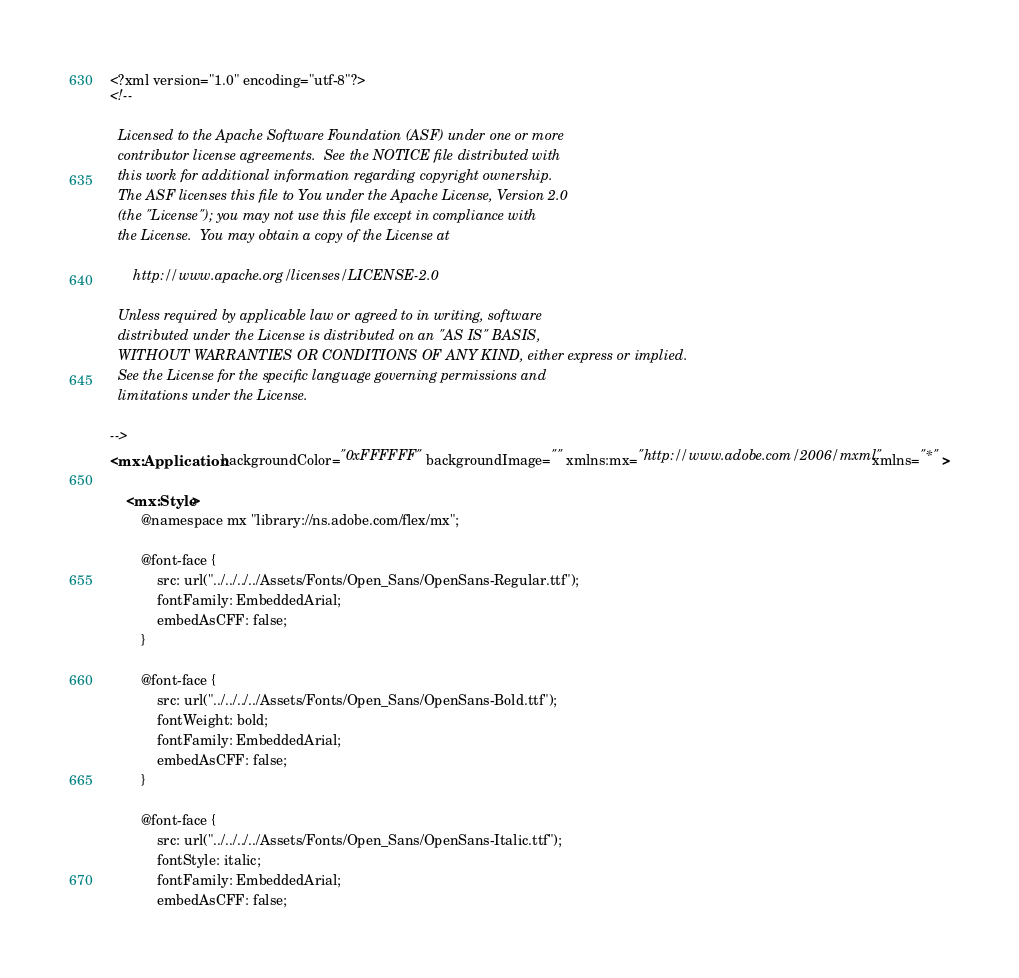<code> <loc_0><loc_0><loc_500><loc_500><_XML_><?xml version="1.0" encoding="utf-8"?>
<!--

  Licensed to the Apache Software Foundation (ASF) under one or more
  contributor license agreements.  See the NOTICE file distributed with
  this work for additional information regarding copyright ownership.
  The ASF licenses this file to You under the Apache License, Version 2.0
  (the "License"); you may not use this file except in compliance with
  the License.  You may obtain a copy of the License at

      http://www.apache.org/licenses/LICENSE-2.0

  Unless required by applicable law or agreed to in writing, software
  distributed under the License is distributed on an "AS IS" BASIS,
  WITHOUT WARRANTIES OR CONDITIONS OF ANY KIND, either express or implied.
  See the License for the specific language governing permissions and
  limitations under the License.

-->
<mx:Application backgroundColor="0xFFFFFF" backgroundImage="" xmlns:mx="http://www.adobe.com/2006/mxml" xmlns="*" >

	<mx:Style>
		@namespace mx "library://ns.adobe.com/flex/mx";
		
		@font-face {
			src: url("../../../../Assets/Fonts/Open_Sans/OpenSans-Regular.ttf");
			fontFamily: EmbeddedArial;
			embedAsCFF: false;
		}

		@font-face {
			src: url("../../../../Assets/Fonts/Open_Sans/OpenSans-Bold.ttf");
			fontWeight: bold;
			fontFamily: EmbeddedArial;
			embedAsCFF: false;
		}

		@font-face {
			src: url("../../../../Assets/Fonts/Open_Sans/OpenSans-Italic.ttf");
			fontStyle: italic;
			fontFamily: EmbeddedArial;
			embedAsCFF: false;</code> 